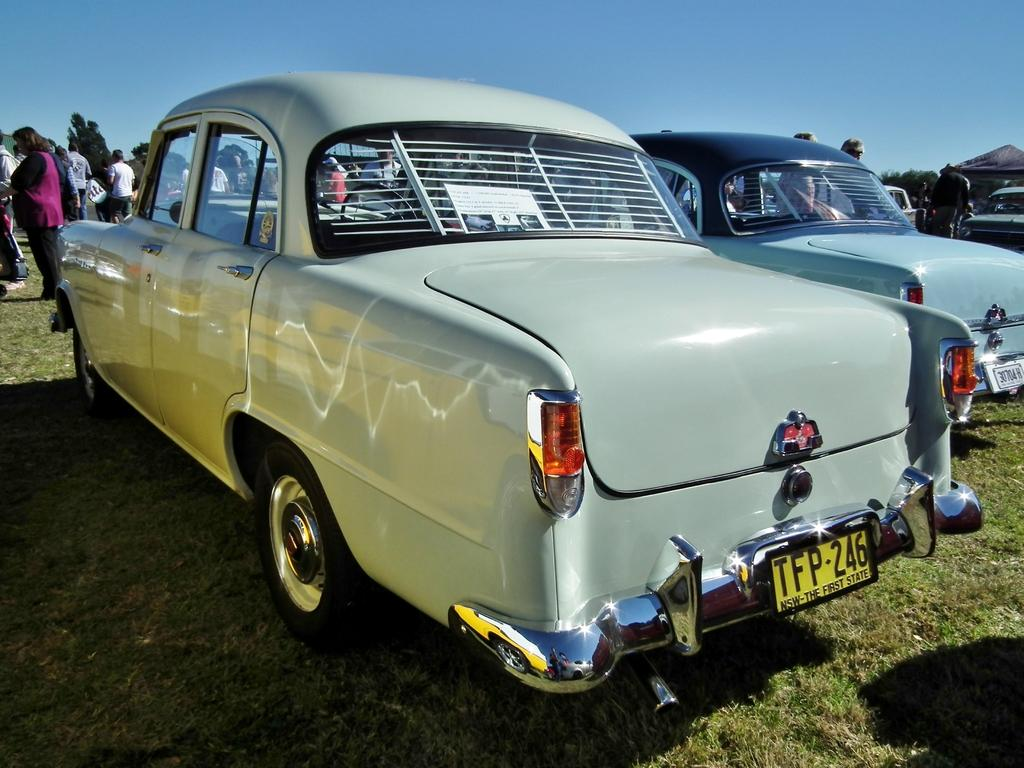What can be seen parked in the image? There are cars parked in the image. What else is visible in the image besides the parked cars? There are people standing in the image, and there is grass on the ground. What type of vegetation is present in the image? There are trees in the image. What color is the sky in the image? The sky is blue in the image. Where is the cave located in the image? There is no cave present in the image. What type of screw can be seen holding the cars together in the image? There are no screws visible in the image, and the cars are not held together; they are parked separately. 